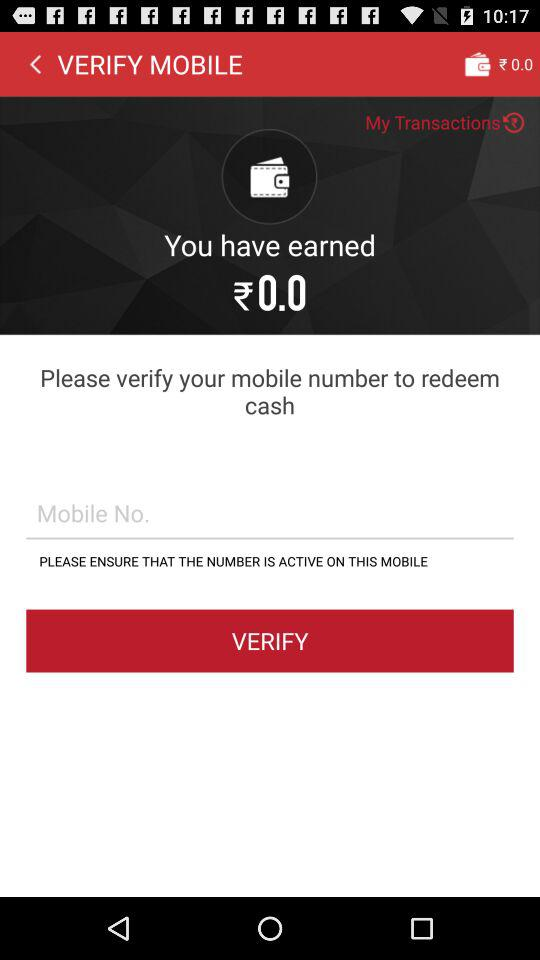How much money was earned? The earned money was ₹0.0. 